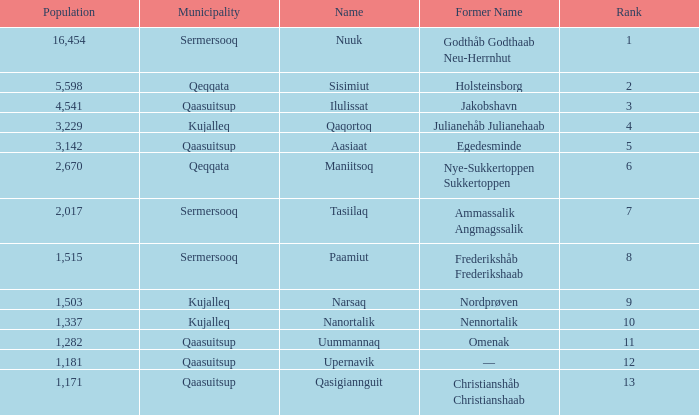What is the population for Rank 11? 1282.0. 